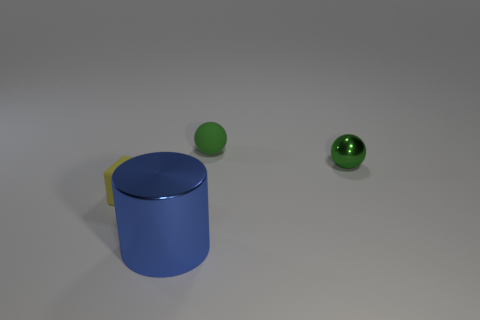Add 4 green shiny things. How many objects exist? 8 Subtract 0 gray spheres. How many objects are left? 4 Subtract all yellow spheres. Subtract all blue cubes. How many spheres are left? 2 Subtract all blue cubes. Subtract all matte things. How many objects are left? 2 Add 2 large blue objects. How many large blue objects are left? 3 Add 2 tiny yellow matte blocks. How many tiny yellow matte blocks exist? 3 